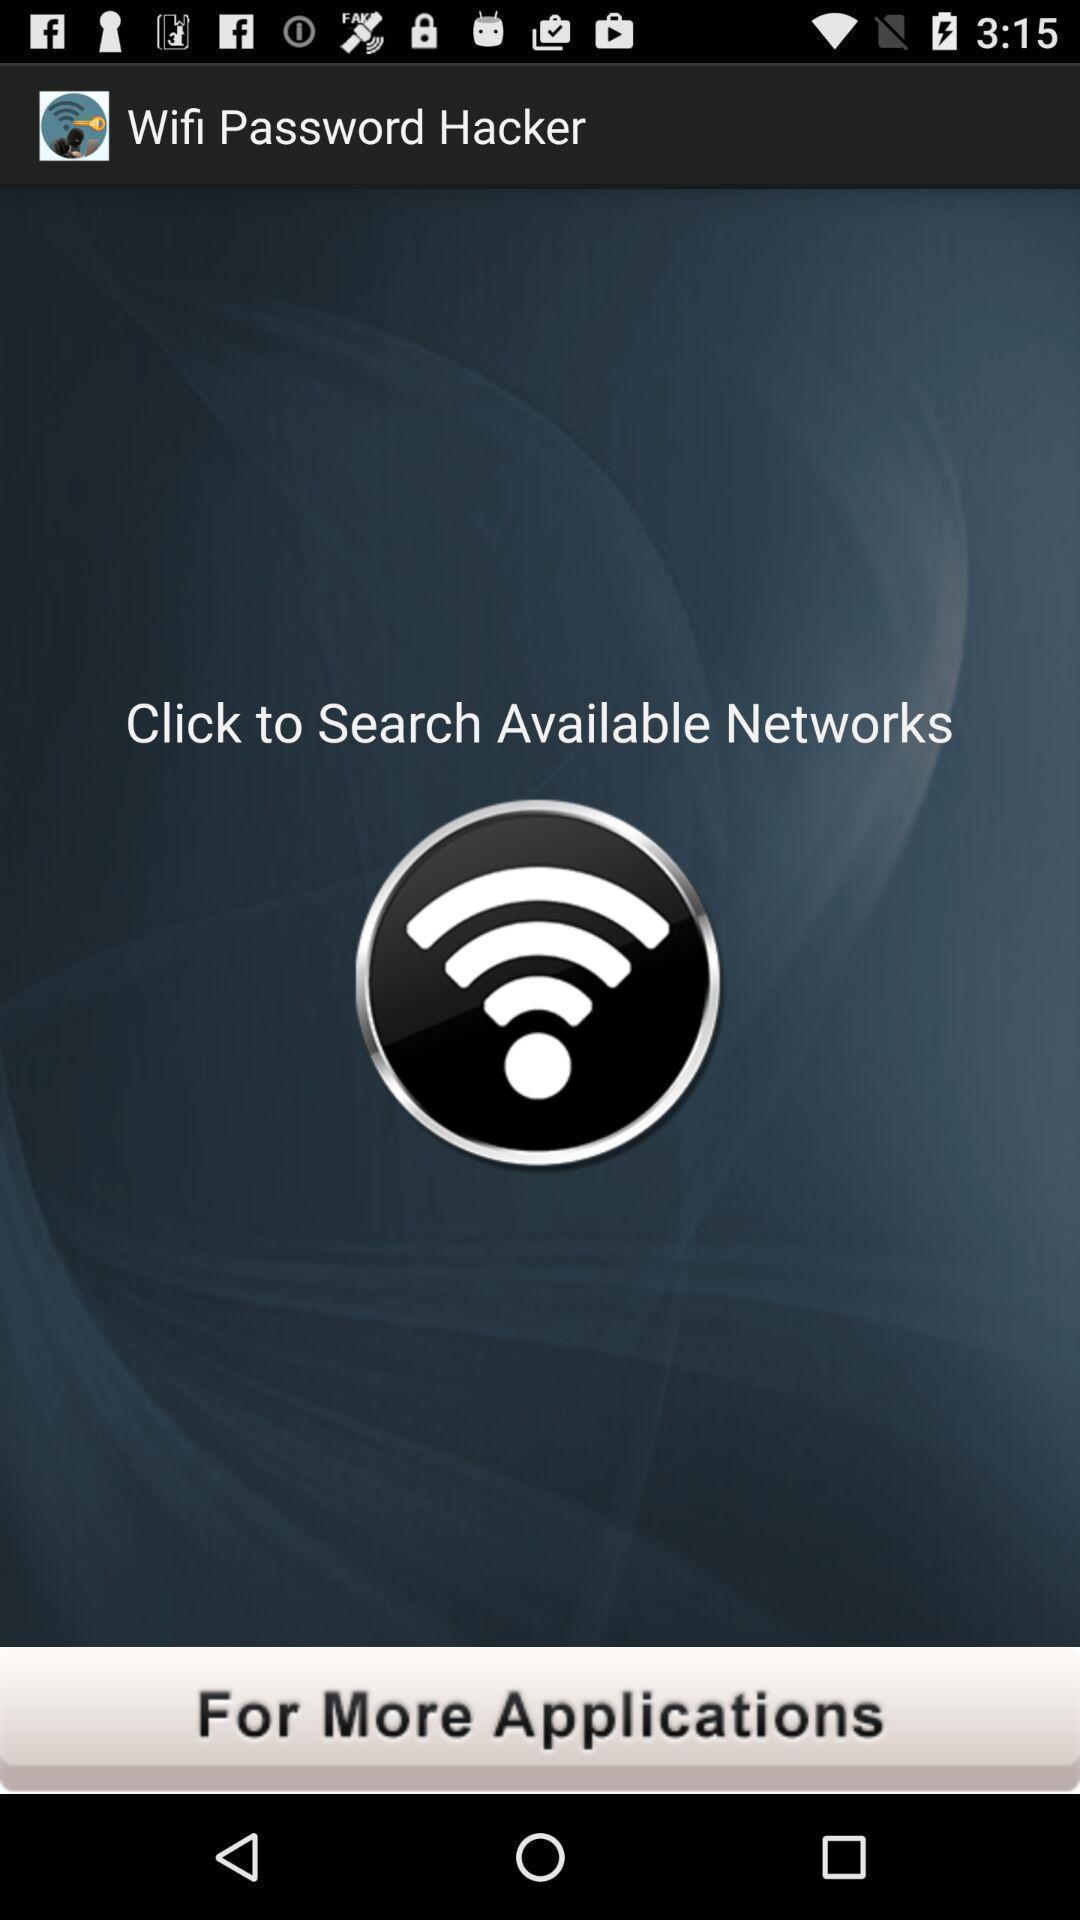Summarize the information in this screenshot. Window displaying a wifi page. 